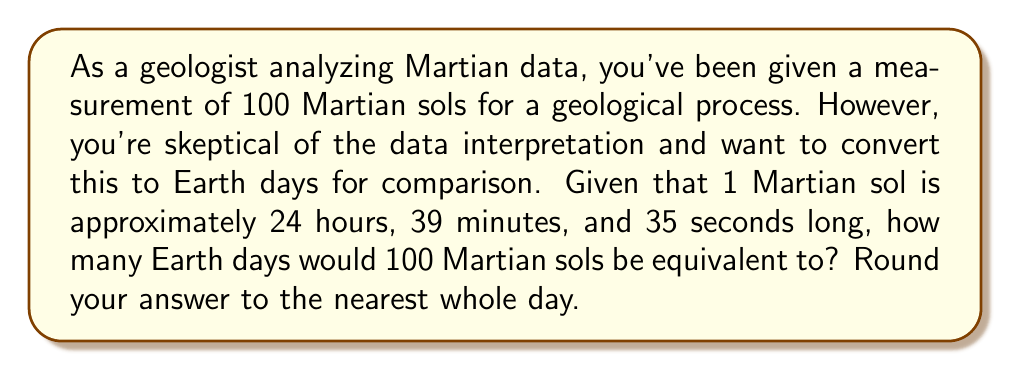Help me with this question. To solve this problem, we need to convert Martian sols to Earth days. Let's break it down step-by-step:

1. First, let's convert 1 Martian sol to seconds:
   $24 \text{ hours} \times 60 \text{ minutes} \times 60 \text{ seconds} = 86400 \text{ seconds}$
   $39 \text{ minutes} \times 60 \text{ seconds} = 2340 \text{ seconds}$
   $35 \text{ seconds}$
   
   Total: $86400 + 2340 + 35 = 88775 \text{ seconds}$

2. Now, let's calculate how many seconds are in 100 Martian sols:
   $100 \times 88775 = 8877500 \text{ seconds}$

3. To convert this to Earth days, we need to divide by the number of seconds in an Earth day:
   $1 \text{ Earth day} = 24 \text{ hours} \times 60 \text{ minutes} \times 60 \text{ seconds} = 86400 \text{ seconds}$

4. Now we can calculate the number of Earth days:
   $$\text{Earth days} = \frac{8877500 \text{ seconds}}{86400 \text{ seconds/day}} \approx 102.7488 \text{ days}$$

5. Rounding to the nearest whole day:
   $102.7488 \text{ days} \approx 103 \text{ days}$
Answer: 103 Earth days 